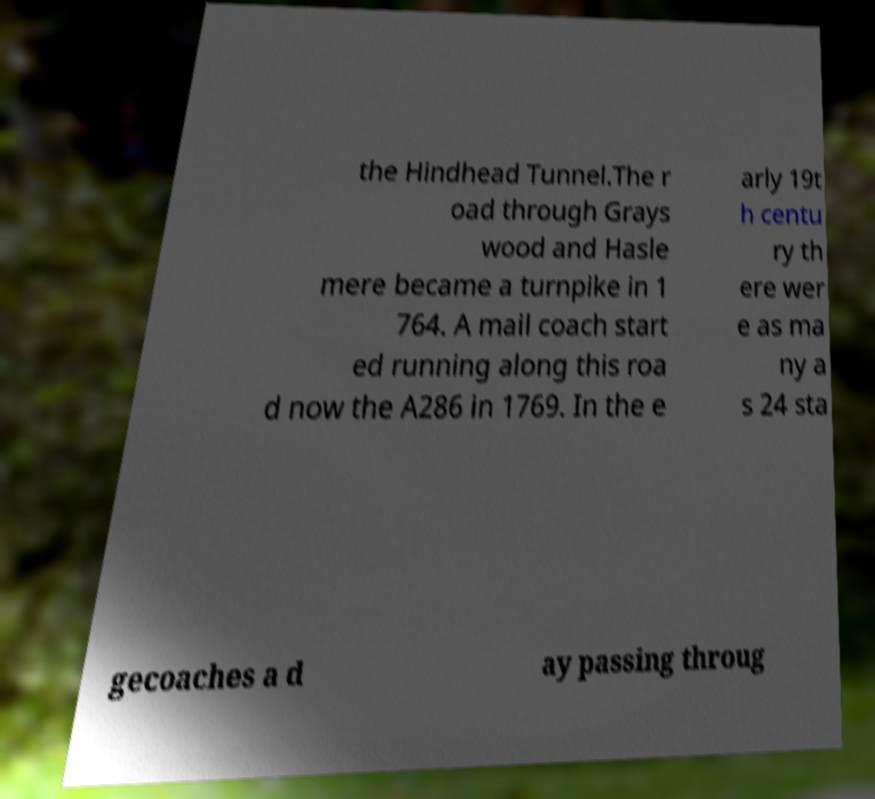I need the written content from this picture converted into text. Can you do that? the Hindhead Tunnel.The r oad through Grays wood and Hasle mere became a turnpike in 1 764. A mail coach start ed running along this roa d now the A286 in 1769. In the e arly 19t h centu ry th ere wer e as ma ny a s 24 sta gecoaches a d ay passing throug 